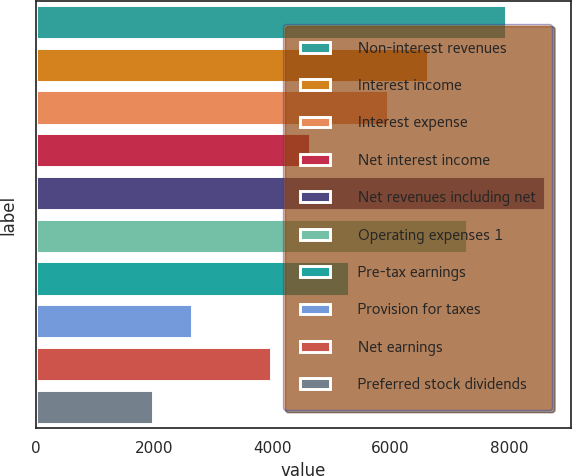Convert chart. <chart><loc_0><loc_0><loc_500><loc_500><bar_chart><fcel>Non-interest revenues<fcel>Interest income<fcel>Interest expense<fcel>Net interest income<fcel>Net revenues including net<fcel>Operating expenses 1<fcel>Pre-tax earnings<fcel>Provision for taxes<fcel>Net earnings<fcel>Preferred stock dividends<nl><fcel>7952.26<fcel>6626.96<fcel>5964.31<fcel>4639.01<fcel>8614.91<fcel>7289.61<fcel>5301.66<fcel>2651.06<fcel>3976.36<fcel>1988.41<nl></chart> 